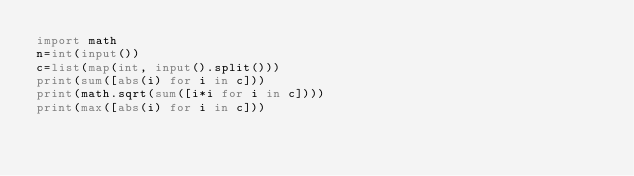Convert code to text. <code><loc_0><loc_0><loc_500><loc_500><_Python_>import math
n=int(input())
c=list(map(int, input().split()))
print(sum([abs(i) for i in c]))
print(math.sqrt(sum([i*i for i in c])))
print(max([abs(i) for i in c]))</code> 